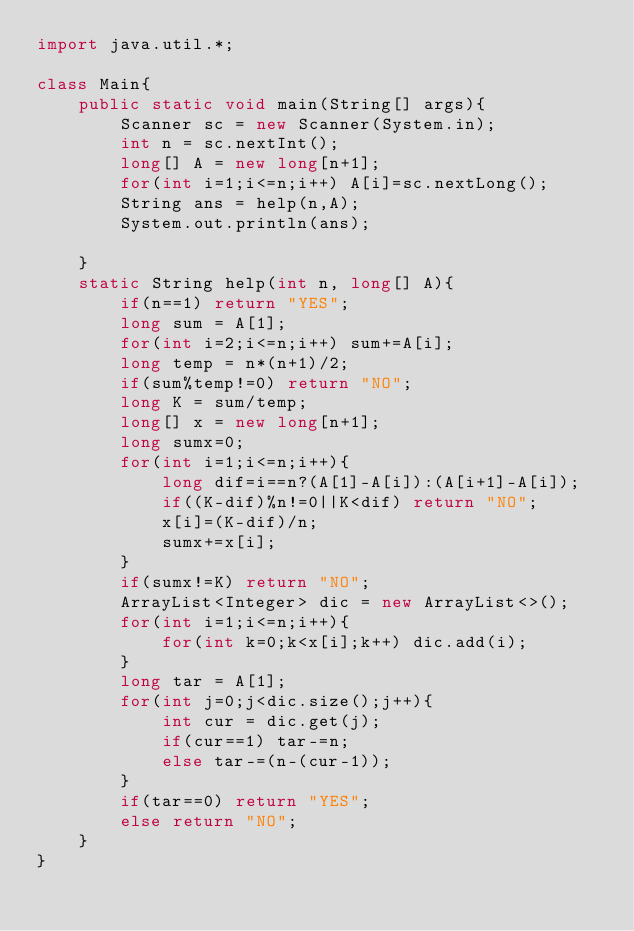Convert code to text. <code><loc_0><loc_0><loc_500><loc_500><_Java_>import java.util.*;

class Main{
    public static void main(String[] args){
        Scanner sc = new Scanner(System.in);
        int n = sc.nextInt();
        long[] A = new long[n+1];
        for(int i=1;i<=n;i++) A[i]=sc.nextLong();
        String ans = help(n,A);
        System.out.println(ans);

    }
    static String help(int n, long[] A){
        if(n==1) return "YES";
        long sum = A[1];
        for(int i=2;i<=n;i++) sum+=A[i];
        long temp = n*(n+1)/2;
        if(sum%temp!=0) return "NO";
        long K = sum/temp;
        long[] x = new long[n+1];
        long sumx=0;
        for(int i=1;i<=n;i++){
            long dif=i==n?(A[1]-A[i]):(A[i+1]-A[i]);
            if((K-dif)%n!=0||K<dif) return "NO";
            x[i]=(K-dif)/n;
            sumx+=x[i];
        }
        if(sumx!=K) return "NO";
        ArrayList<Integer> dic = new ArrayList<>();
        for(int i=1;i<=n;i++){
            for(int k=0;k<x[i];k++) dic.add(i);
        }
        long tar = A[1];
        for(int j=0;j<dic.size();j++){
            int cur = dic.get(j);
            if(cur==1) tar-=n;
            else tar-=(n-(cur-1));
        }
        if(tar==0) return "YES";
        else return "NO";
    }
}
</code> 